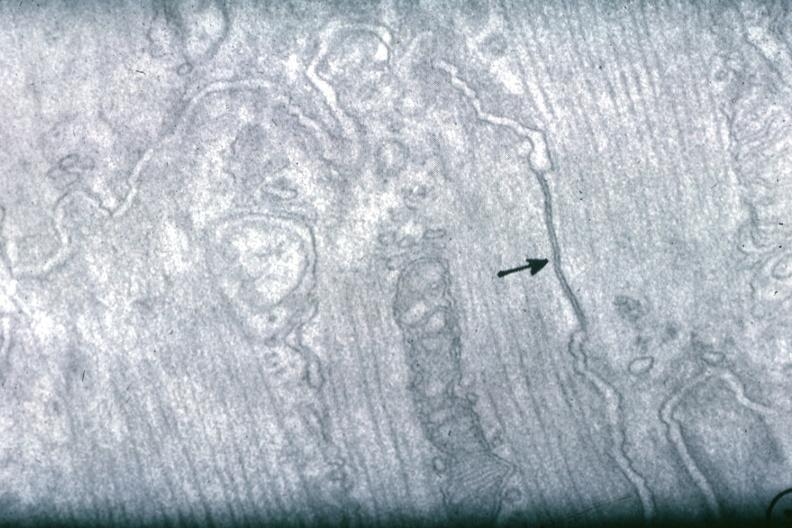s myocardium present?
Answer the question using a single word or phrase. Yes 